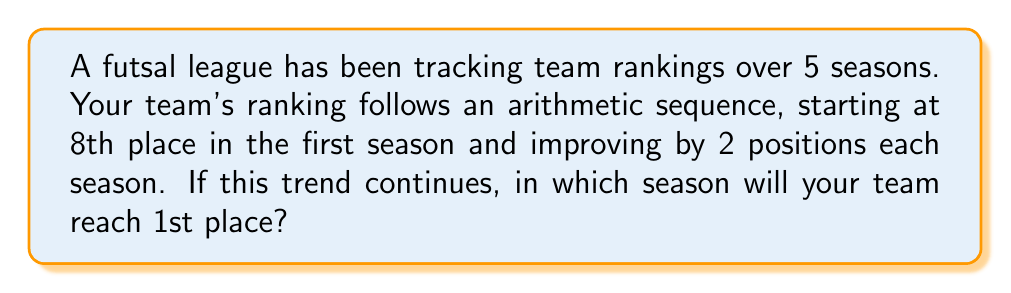Provide a solution to this math problem. Let's approach this step-by-step:

1) We have an arithmetic sequence with:
   - First term (a₁) = 8 (8th place in the first season)
   - Common difference (d) = -2 (improving by 2 positions each season, so we subtract 2)

2) We want to find when the term will be 1 (1st place). Let's call this term 'n'.

3) The formula for the nth term of an arithmetic sequence is:
   $$ a_n = a_1 + (n-1)d $$

4) Substituting our values:
   $$ 1 = 8 + (n-1)(-2) $$

5) Simplify:
   $$ 1 = 8 - 2n + 2 $$
   $$ 1 = 10 - 2n $$

6) Subtract 10 from both sides:
   $$ -9 = -2n $$

7) Divide both sides by -2:
   $$ \frac{9}{2} = n $$

8) Since n represents seasons, we need to round up to the next whole number:
   $$ n = 5 $$

Therefore, your team will reach 1st place in the 5th season.
Answer: 5th season 